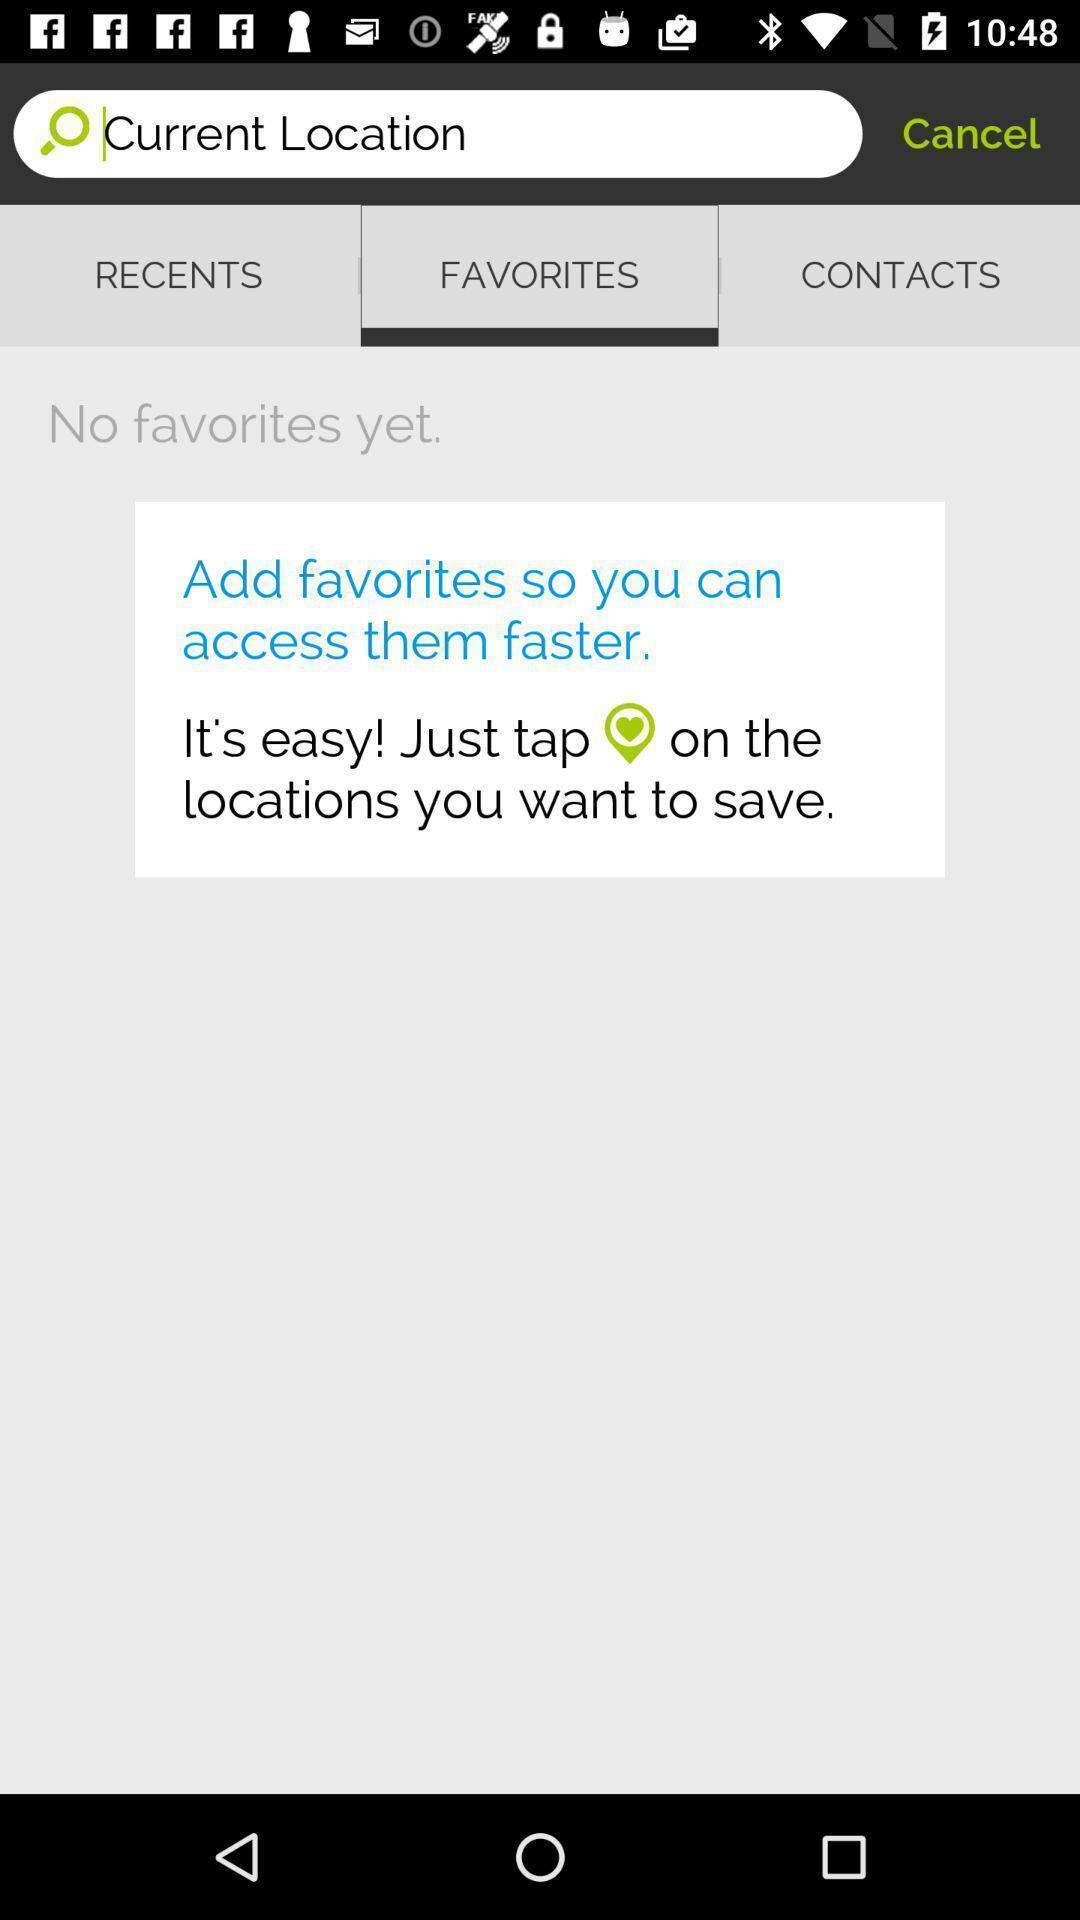What is the overall content of this screenshot? Search page for the navigation app. 